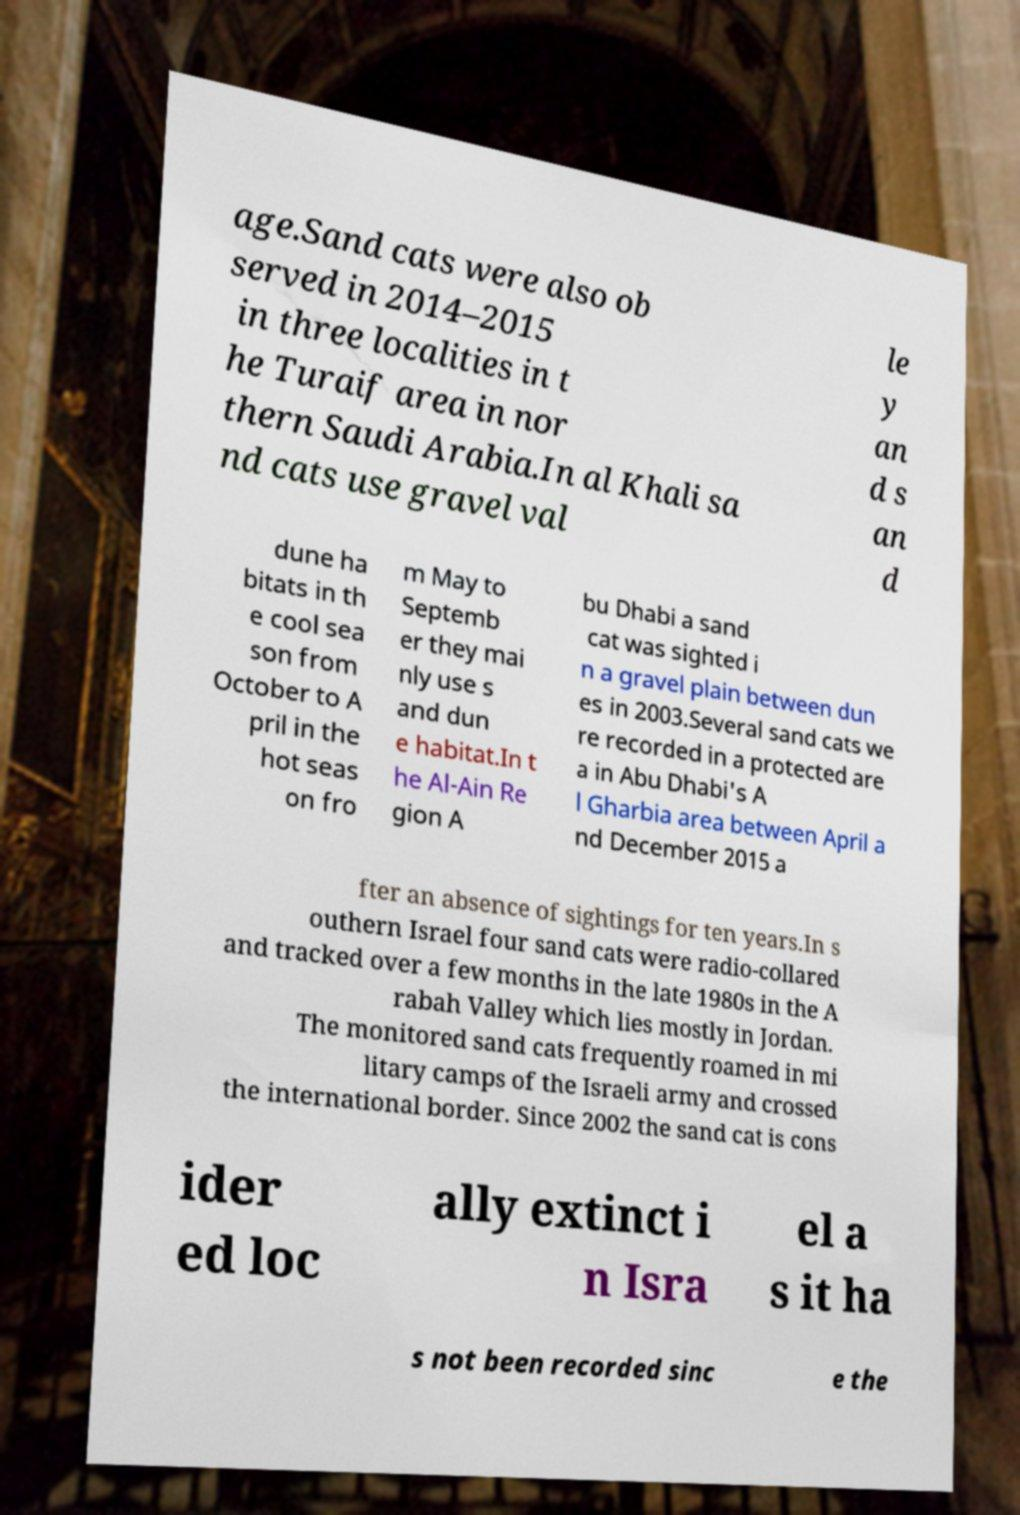Could you extract and type out the text from this image? age.Sand cats were also ob served in 2014–2015 in three localities in t he Turaif area in nor thern Saudi Arabia.In al Khali sa nd cats use gravel val le y an d s an d dune ha bitats in th e cool sea son from October to A pril in the hot seas on fro m May to Septemb er they mai nly use s and dun e habitat.In t he Al-Ain Re gion A bu Dhabi a sand cat was sighted i n a gravel plain between dun es in 2003.Several sand cats we re recorded in a protected are a in Abu Dhabi's A l Gharbia area between April a nd December 2015 a fter an absence of sightings for ten years.In s outhern Israel four sand cats were radio-collared and tracked over a few months in the late 1980s in the A rabah Valley which lies mostly in Jordan. The monitored sand cats frequently roamed in mi litary camps of the Israeli army and crossed the international border. Since 2002 the sand cat is cons ider ed loc ally extinct i n Isra el a s it ha s not been recorded sinc e the 